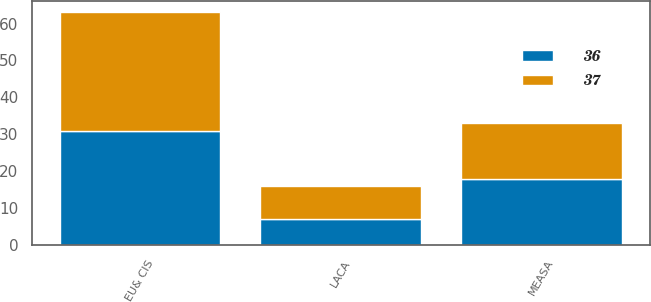<chart> <loc_0><loc_0><loc_500><loc_500><stacked_bar_chart><ecel><fcel>EU& CIS<fcel>MEASA<fcel>LACA<nl><fcel>37<fcel>32<fcel>15<fcel>9<nl><fcel>36<fcel>31<fcel>18<fcel>7<nl></chart> 